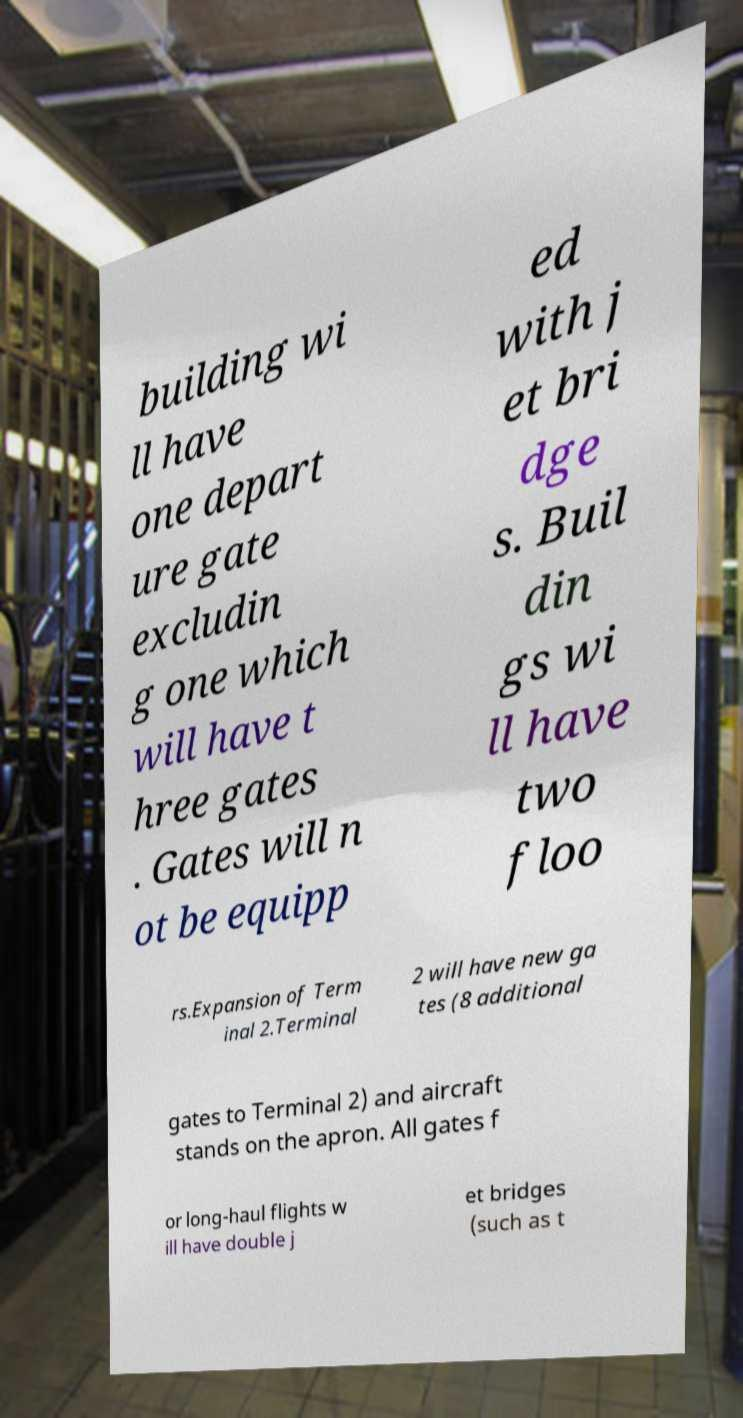Can you read and provide the text displayed in the image?This photo seems to have some interesting text. Can you extract and type it out for me? building wi ll have one depart ure gate excludin g one which will have t hree gates . Gates will n ot be equipp ed with j et bri dge s. Buil din gs wi ll have two floo rs.Expansion of Term inal 2.Terminal 2 will have new ga tes (8 additional gates to Terminal 2) and aircraft stands on the apron. All gates f or long-haul flights w ill have double j et bridges (such as t 